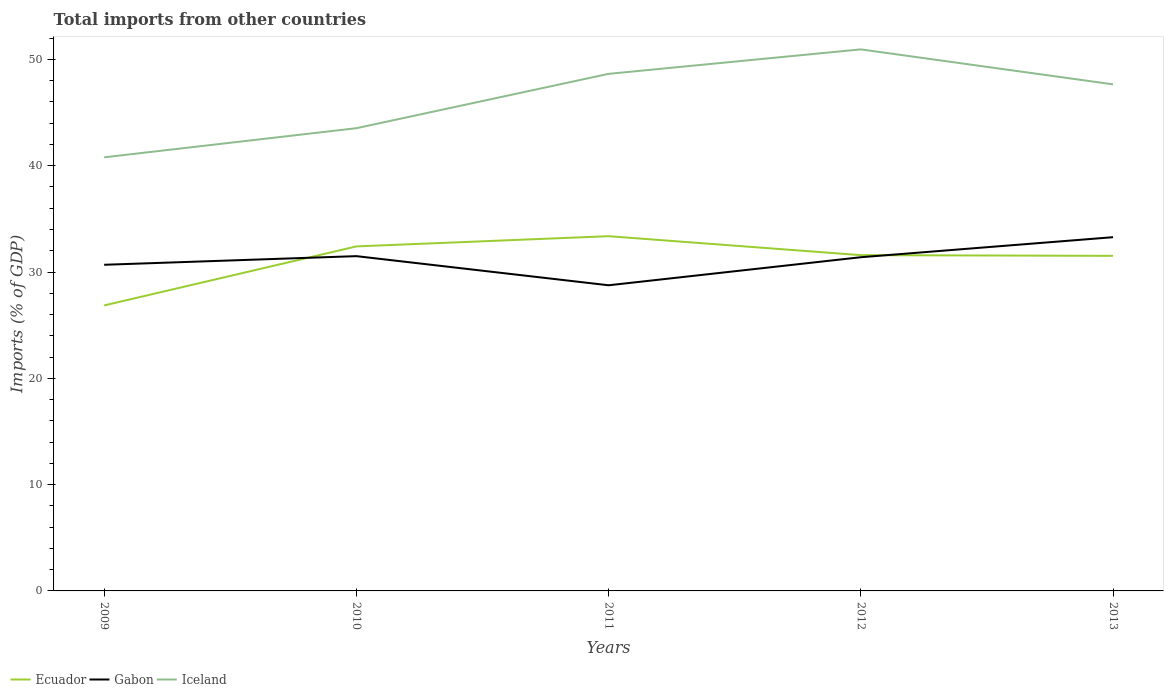How many different coloured lines are there?
Provide a succinct answer. 3. Is the number of lines equal to the number of legend labels?
Provide a succinct answer. Yes. Across all years, what is the maximum total imports in Ecuador?
Offer a very short reply. 26.86. What is the total total imports in Iceland in the graph?
Give a very brief answer. -6.86. What is the difference between the highest and the second highest total imports in Ecuador?
Provide a succinct answer. 6.51. Is the total imports in Iceland strictly greater than the total imports in Ecuador over the years?
Give a very brief answer. No. How many lines are there?
Keep it short and to the point. 3. Are the values on the major ticks of Y-axis written in scientific E-notation?
Your answer should be very brief. No. Does the graph contain grids?
Offer a very short reply. No. Where does the legend appear in the graph?
Ensure brevity in your answer.  Bottom left. How many legend labels are there?
Ensure brevity in your answer.  3. How are the legend labels stacked?
Make the answer very short. Horizontal. What is the title of the graph?
Ensure brevity in your answer.  Total imports from other countries. Does "Channel Islands" appear as one of the legend labels in the graph?
Your response must be concise. No. What is the label or title of the X-axis?
Ensure brevity in your answer.  Years. What is the label or title of the Y-axis?
Keep it short and to the point. Imports (% of GDP). What is the Imports (% of GDP) of Ecuador in 2009?
Offer a terse response. 26.86. What is the Imports (% of GDP) of Gabon in 2009?
Your answer should be very brief. 30.68. What is the Imports (% of GDP) in Iceland in 2009?
Provide a short and direct response. 40.79. What is the Imports (% of GDP) in Ecuador in 2010?
Offer a very short reply. 32.41. What is the Imports (% of GDP) of Gabon in 2010?
Give a very brief answer. 31.49. What is the Imports (% of GDP) of Iceland in 2010?
Provide a succinct answer. 43.53. What is the Imports (% of GDP) in Ecuador in 2011?
Make the answer very short. 33.37. What is the Imports (% of GDP) in Gabon in 2011?
Keep it short and to the point. 28.75. What is the Imports (% of GDP) of Iceland in 2011?
Provide a short and direct response. 48.64. What is the Imports (% of GDP) of Ecuador in 2012?
Give a very brief answer. 31.59. What is the Imports (% of GDP) in Gabon in 2012?
Ensure brevity in your answer.  31.39. What is the Imports (% of GDP) in Iceland in 2012?
Offer a very short reply. 50.94. What is the Imports (% of GDP) in Ecuador in 2013?
Give a very brief answer. 31.52. What is the Imports (% of GDP) in Gabon in 2013?
Your response must be concise. 33.28. What is the Imports (% of GDP) of Iceland in 2013?
Your answer should be compact. 47.65. Across all years, what is the maximum Imports (% of GDP) of Ecuador?
Your response must be concise. 33.37. Across all years, what is the maximum Imports (% of GDP) of Gabon?
Your answer should be compact. 33.28. Across all years, what is the maximum Imports (% of GDP) of Iceland?
Provide a succinct answer. 50.94. Across all years, what is the minimum Imports (% of GDP) in Ecuador?
Your response must be concise. 26.86. Across all years, what is the minimum Imports (% of GDP) in Gabon?
Your response must be concise. 28.75. Across all years, what is the minimum Imports (% of GDP) in Iceland?
Provide a short and direct response. 40.79. What is the total Imports (% of GDP) of Ecuador in the graph?
Offer a terse response. 155.74. What is the total Imports (% of GDP) in Gabon in the graph?
Keep it short and to the point. 155.59. What is the total Imports (% of GDP) of Iceland in the graph?
Your response must be concise. 231.55. What is the difference between the Imports (% of GDP) in Ecuador in 2009 and that in 2010?
Keep it short and to the point. -5.55. What is the difference between the Imports (% of GDP) in Gabon in 2009 and that in 2010?
Offer a very short reply. -0.81. What is the difference between the Imports (% of GDP) in Iceland in 2009 and that in 2010?
Provide a succinct answer. -2.74. What is the difference between the Imports (% of GDP) in Ecuador in 2009 and that in 2011?
Make the answer very short. -6.51. What is the difference between the Imports (% of GDP) in Gabon in 2009 and that in 2011?
Your response must be concise. 1.93. What is the difference between the Imports (% of GDP) in Iceland in 2009 and that in 2011?
Provide a short and direct response. -7.85. What is the difference between the Imports (% of GDP) in Ecuador in 2009 and that in 2012?
Provide a succinct answer. -4.73. What is the difference between the Imports (% of GDP) in Gabon in 2009 and that in 2012?
Ensure brevity in your answer.  -0.71. What is the difference between the Imports (% of GDP) of Iceland in 2009 and that in 2012?
Your answer should be very brief. -10.15. What is the difference between the Imports (% of GDP) of Ecuador in 2009 and that in 2013?
Your answer should be very brief. -4.66. What is the difference between the Imports (% of GDP) in Gabon in 2009 and that in 2013?
Offer a very short reply. -2.6. What is the difference between the Imports (% of GDP) in Iceland in 2009 and that in 2013?
Provide a short and direct response. -6.86. What is the difference between the Imports (% of GDP) in Ecuador in 2010 and that in 2011?
Provide a short and direct response. -0.96. What is the difference between the Imports (% of GDP) in Gabon in 2010 and that in 2011?
Keep it short and to the point. 2.74. What is the difference between the Imports (% of GDP) of Iceland in 2010 and that in 2011?
Keep it short and to the point. -5.11. What is the difference between the Imports (% of GDP) of Ecuador in 2010 and that in 2012?
Keep it short and to the point. 0.82. What is the difference between the Imports (% of GDP) of Gabon in 2010 and that in 2012?
Your answer should be compact. 0.1. What is the difference between the Imports (% of GDP) of Iceland in 2010 and that in 2012?
Your answer should be very brief. -7.41. What is the difference between the Imports (% of GDP) of Ecuador in 2010 and that in 2013?
Provide a succinct answer. 0.89. What is the difference between the Imports (% of GDP) of Gabon in 2010 and that in 2013?
Provide a succinct answer. -1.78. What is the difference between the Imports (% of GDP) of Iceland in 2010 and that in 2013?
Make the answer very short. -4.12. What is the difference between the Imports (% of GDP) in Ecuador in 2011 and that in 2012?
Make the answer very short. 1.78. What is the difference between the Imports (% of GDP) of Gabon in 2011 and that in 2012?
Provide a succinct answer. -2.64. What is the difference between the Imports (% of GDP) of Iceland in 2011 and that in 2012?
Make the answer very short. -2.3. What is the difference between the Imports (% of GDP) of Ecuador in 2011 and that in 2013?
Offer a very short reply. 1.85. What is the difference between the Imports (% of GDP) of Gabon in 2011 and that in 2013?
Your answer should be very brief. -4.52. What is the difference between the Imports (% of GDP) of Iceland in 2011 and that in 2013?
Make the answer very short. 0.99. What is the difference between the Imports (% of GDP) in Ecuador in 2012 and that in 2013?
Offer a terse response. 0.07. What is the difference between the Imports (% of GDP) in Gabon in 2012 and that in 2013?
Keep it short and to the point. -1.89. What is the difference between the Imports (% of GDP) in Iceland in 2012 and that in 2013?
Your answer should be compact. 3.29. What is the difference between the Imports (% of GDP) of Ecuador in 2009 and the Imports (% of GDP) of Gabon in 2010?
Keep it short and to the point. -4.64. What is the difference between the Imports (% of GDP) in Ecuador in 2009 and the Imports (% of GDP) in Iceland in 2010?
Keep it short and to the point. -16.67. What is the difference between the Imports (% of GDP) of Gabon in 2009 and the Imports (% of GDP) of Iceland in 2010?
Your answer should be very brief. -12.85. What is the difference between the Imports (% of GDP) in Ecuador in 2009 and the Imports (% of GDP) in Gabon in 2011?
Ensure brevity in your answer.  -1.9. What is the difference between the Imports (% of GDP) in Ecuador in 2009 and the Imports (% of GDP) in Iceland in 2011?
Your answer should be compact. -21.78. What is the difference between the Imports (% of GDP) in Gabon in 2009 and the Imports (% of GDP) in Iceland in 2011?
Offer a very short reply. -17.96. What is the difference between the Imports (% of GDP) of Ecuador in 2009 and the Imports (% of GDP) of Gabon in 2012?
Make the answer very short. -4.54. What is the difference between the Imports (% of GDP) of Ecuador in 2009 and the Imports (% of GDP) of Iceland in 2012?
Make the answer very short. -24.09. What is the difference between the Imports (% of GDP) in Gabon in 2009 and the Imports (% of GDP) in Iceland in 2012?
Give a very brief answer. -20.26. What is the difference between the Imports (% of GDP) of Ecuador in 2009 and the Imports (% of GDP) of Gabon in 2013?
Provide a short and direct response. -6.42. What is the difference between the Imports (% of GDP) of Ecuador in 2009 and the Imports (% of GDP) of Iceland in 2013?
Give a very brief answer. -20.8. What is the difference between the Imports (% of GDP) in Gabon in 2009 and the Imports (% of GDP) in Iceland in 2013?
Ensure brevity in your answer.  -16.97. What is the difference between the Imports (% of GDP) of Ecuador in 2010 and the Imports (% of GDP) of Gabon in 2011?
Offer a terse response. 3.66. What is the difference between the Imports (% of GDP) of Ecuador in 2010 and the Imports (% of GDP) of Iceland in 2011?
Make the answer very short. -16.23. What is the difference between the Imports (% of GDP) of Gabon in 2010 and the Imports (% of GDP) of Iceland in 2011?
Offer a very short reply. -17.15. What is the difference between the Imports (% of GDP) in Ecuador in 2010 and the Imports (% of GDP) in Gabon in 2012?
Provide a succinct answer. 1.02. What is the difference between the Imports (% of GDP) of Ecuador in 2010 and the Imports (% of GDP) of Iceland in 2012?
Make the answer very short. -18.53. What is the difference between the Imports (% of GDP) in Gabon in 2010 and the Imports (% of GDP) in Iceland in 2012?
Ensure brevity in your answer.  -19.45. What is the difference between the Imports (% of GDP) in Ecuador in 2010 and the Imports (% of GDP) in Gabon in 2013?
Provide a short and direct response. -0.87. What is the difference between the Imports (% of GDP) of Ecuador in 2010 and the Imports (% of GDP) of Iceland in 2013?
Your answer should be very brief. -15.24. What is the difference between the Imports (% of GDP) in Gabon in 2010 and the Imports (% of GDP) in Iceland in 2013?
Provide a succinct answer. -16.16. What is the difference between the Imports (% of GDP) of Ecuador in 2011 and the Imports (% of GDP) of Gabon in 2012?
Make the answer very short. 1.98. What is the difference between the Imports (% of GDP) in Ecuador in 2011 and the Imports (% of GDP) in Iceland in 2012?
Give a very brief answer. -17.57. What is the difference between the Imports (% of GDP) in Gabon in 2011 and the Imports (% of GDP) in Iceland in 2012?
Provide a short and direct response. -22.19. What is the difference between the Imports (% of GDP) of Ecuador in 2011 and the Imports (% of GDP) of Gabon in 2013?
Keep it short and to the point. 0.09. What is the difference between the Imports (% of GDP) of Ecuador in 2011 and the Imports (% of GDP) of Iceland in 2013?
Your answer should be very brief. -14.28. What is the difference between the Imports (% of GDP) in Gabon in 2011 and the Imports (% of GDP) in Iceland in 2013?
Offer a very short reply. -18.9. What is the difference between the Imports (% of GDP) of Ecuador in 2012 and the Imports (% of GDP) of Gabon in 2013?
Provide a short and direct response. -1.69. What is the difference between the Imports (% of GDP) of Ecuador in 2012 and the Imports (% of GDP) of Iceland in 2013?
Offer a terse response. -16.07. What is the difference between the Imports (% of GDP) of Gabon in 2012 and the Imports (% of GDP) of Iceland in 2013?
Offer a very short reply. -16.26. What is the average Imports (% of GDP) in Ecuador per year?
Keep it short and to the point. 31.15. What is the average Imports (% of GDP) in Gabon per year?
Make the answer very short. 31.12. What is the average Imports (% of GDP) in Iceland per year?
Your response must be concise. 46.31. In the year 2009, what is the difference between the Imports (% of GDP) in Ecuador and Imports (% of GDP) in Gabon?
Your response must be concise. -3.82. In the year 2009, what is the difference between the Imports (% of GDP) of Ecuador and Imports (% of GDP) of Iceland?
Offer a terse response. -13.93. In the year 2009, what is the difference between the Imports (% of GDP) in Gabon and Imports (% of GDP) in Iceland?
Ensure brevity in your answer.  -10.11. In the year 2010, what is the difference between the Imports (% of GDP) of Ecuador and Imports (% of GDP) of Gabon?
Give a very brief answer. 0.92. In the year 2010, what is the difference between the Imports (% of GDP) in Ecuador and Imports (% of GDP) in Iceland?
Provide a succinct answer. -11.12. In the year 2010, what is the difference between the Imports (% of GDP) in Gabon and Imports (% of GDP) in Iceland?
Your answer should be very brief. -12.04. In the year 2011, what is the difference between the Imports (% of GDP) of Ecuador and Imports (% of GDP) of Gabon?
Make the answer very short. 4.62. In the year 2011, what is the difference between the Imports (% of GDP) of Ecuador and Imports (% of GDP) of Iceland?
Give a very brief answer. -15.27. In the year 2011, what is the difference between the Imports (% of GDP) of Gabon and Imports (% of GDP) of Iceland?
Offer a very short reply. -19.89. In the year 2012, what is the difference between the Imports (% of GDP) of Ecuador and Imports (% of GDP) of Gabon?
Provide a succinct answer. 0.2. In the year 2012, what is the difference between the Imports (% of GDP) in Ecuador and Imports (% of GDP) in Iceland?
Provide a succinct answer. -19.36. In the year 2012, what is the difference between the Imports (% of GDP) in Gabon and Imports (% of GDP) in Iceland?
Your response must be concise. -19.55. In the year 2013, what is the difference between the Imports (% of GDP) of Ecuador and Imports (% of GDP) of Gabon?
Your answer should be compact. -1.76. In the year 2013, what is the difference between the Imports (% of GDP) in Ecuador and Imports (% of GDP) in Iceland?
Make the answer very short. -16.13. In the year 2013, what is the difference between the Imports (% of GDP) in Gabon and Imports (% of GDP) in Iceland?
Your answer should be compact. -14.38. What is the ratio of the Imports (% of GDP) of Ecuador in 2009 to that in 2010?
Provide a succinct answer. 0.83. What is the ratio of the Imports (% of GDP) of Gabon in 2009 to that in 2010?
Provide a succinct answer. 0.97. What is the ratio of the Imports (% of GDP) in Iceland in 2009 to that in 2010?
Ensure brevity in your answer.  0.94. What is the ratio of the Imports (% of GDP) of Ecuador in 2009 to that in 2011?
Your response must be concise. 0.8. What is the ratio of the Imports (% of GDP) of Gabon in 2009 to that in 2011?
Offer a terse response. 1.07. What is the ratio of the Imports (% of GDP) of Iceland in 2009 to that in 2011?
Provide a short and direct response. 0.84. What is the ratio of the Imports (% of GDP) of Ecuador in 2009 to that in 2012?
Your response must be concise. 0.85. What is the ratio of the Imports (% of GDP) of Gabon in 2009 to that in 2012?
Keep it short and to the point. 0.98. What is the ratio of the Imports (% of GDP) of Iceland in 2009 to that in 2012?
Offer a terse response. 0.8. What is the ratio of the Imports (% of GDP) of Ecuador in 2009 to that in 2013?
Your response must be concise. 0.85. What is the ratio of the Imports (% of GDP) in Gabon in 2009 to that in 2013?
Keep it short and to the point. 0.92. What is the ratio of the Imports (% of GDP) of Iceland in 2009 to that in 2013?
Your answer should be compact. 0.86. What is the ratio of the Imports (% of GDP) of Ecuador in 2010 to that in 2011?
Provide a succinct answer. 0.97. What is the ratio of the Imports (% of GDP) of Gabon in 2010 to that in 2011?
Provide a succinct answer. 1.1. What is the ratio of the Imports (% of GDP) in Iceland in 2010 to that in 2011?
Make the answer very short. 0.89. What is the ratio of the Imports (% of GDP) of Iceland in 2010 to that in 2012?
Your answer should be compact. 0.85. What is the ratio of the Imports (% of GDP) of Ecuador in 2010 to that in 2013?
Offer a terse response. 1.03. What is the ratio of the Imports (% of GDP) of Gabon in 2010 to that in 2013?
Make the answer very short. 0.95. What is the ratio of the Imports (% of GDP) in Iceland in 2010 to that in 2013?
Give a very brief answer. 0.91. What is the ratio of the Imports (% of GDP) in Ecuador in 2011 to that in 2012?
Make the answer very short. 1.06. What is the ratio of the Imports (% of GDP) in Gabon in 2011 to that in 2012?
Your answer should be very brief. 0.92. What is the ratio of the Imports (% of GDP) in Iceland in 2011 to that in 2012?
Offer a terse response. 0.95. What is the ratio of the Imports (% of GDP) in Ecuador in 2011 to that in 2013?
Offer a very short reply. 1.06. What is the ratio of the Imports (% of GDP) of Gabon in 2011 to that in 2013?
Provide a short and direct response. 0.86. What is the ratio of the Imports (% of GDP) in Iceland in 2011 to that in 2013?
Offer a terse response. 1.02. What is the ratio of the Imports (% of GDP) in Ecuador in 2012 to that in 2013?
Your answer should be very brief. 1. What is the ratio of the Imports (% of GDP) in Gabon in 2012 to that in 2013?
Your answer should be compact. 0.94. What is the ratio of the Imports (% of GDP) in Iceland in 2012 to that in 2013?
Offer a terse response. 1.07. What is the difference between the highest and the second highest Imports (% of GDP) in Ecuador?
Provide a succinct answer. 0.96. What is the difference between the highest and the second highest Imports (% of GDP) of Gabon?
Offer a terse response. 1.78. What is the difference between the highest and the second highest Imports (% of GDP) in Iceland?
Provide a short and direct response. 2.3. What is the difference between the highest and the lowest Imports (% of GDP) of Ecuador?
Your answer should be very brief. 6.51. What is the difference between the highest and the lowest Imports (% of GDP) of Gabon?
Offer a very short reply. 4.52. What is the difference between the highest and the lowest Imports (% of GDP) in Iceland?
Your answer should be very brief. 10.15. 